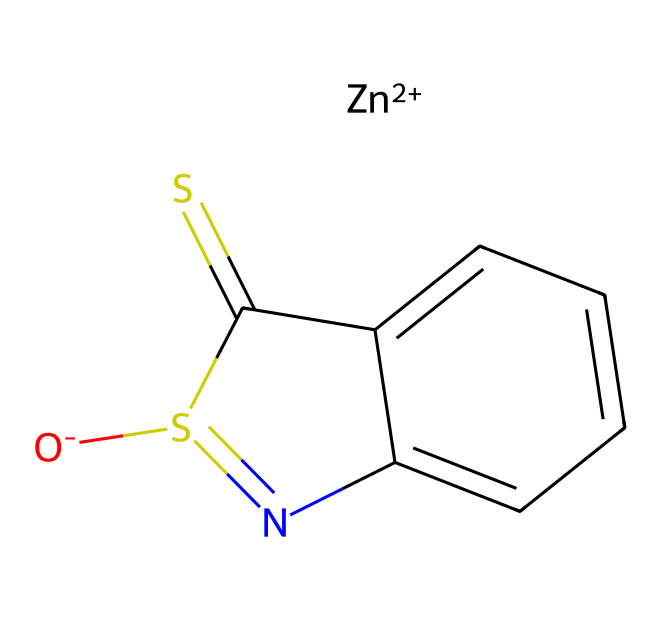how many zinc atoms are in the structure? The SMILES representation indicates there is one zinc ion denoted by [Zn+2], which shows that there is exactly one zinc atom in this coordination compound.
Answer: one what is the oxidation state of zinc in this compound? The notation [Zn+2] indicates that zinc is in the +2 oxidation state. This means that it has lost two electrons and carries a positive charge.
Answer: +2 how many nitrogen atoms are present in zinc pyrithione? By analyzing the structure in the SMILES representation, there are two nitrogen atoms present in the pyrithione ring structure.
Answer: two what type of bonding occurs between zinc and the ligand? Zinc forms coordinate covalent bonds with the ligand, where both electrons in the bond originate from the ligand, facilitating the coordination of the zinc ion.
Answer: coordinate covalent what structural feature of zinc pyrithione contributes to its antimicrobial properties? The presence of the sulfur atom in the chemical structure, linked to the pyridone ring, is important for the antimicrobial activity of zinc pyrithione, allowing it to interact with biological molecules effectively.
Answer: sulfur atom what type of coordination compound is zinc pyrithione classified as? Zinc pyrithione is classified as a chelate complex, as it has a central metal atom (zinc) bonded to a ligand that forms a ring structure encompassing the metal.
Answer: chelate complex 